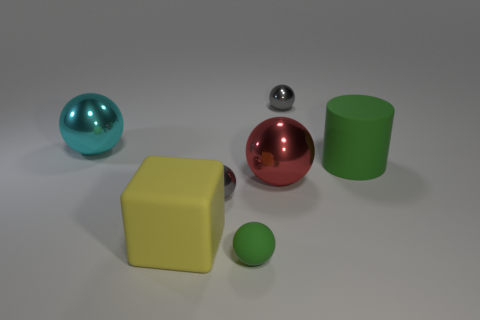There is another thing that is the same color as the tiny matte thing; what material is it?
Your answer should be very brief. Rubber. Are there any tiny spheres that are on the left side of the large shiny ball that is in front of the big cylinder?
Ensure brevity in your answer.  Yes. There is a ball that is behind the large green rubber cylinder and to the left of the big red ball; what is its size?
Offer a terse response. Large. What number of green things are metallic things or big objects?
Offer a terse response. 1. The red metal object that is the same size as the yellow thing is what shape?
Ensure brevity in your answer.  Sphere. How many other objects are there of the same color as the large rubber block?
Offer a very short reply. 0. What size is the red metal ball in front of the big cyan object on the left side of the tiny rubber sphere?
Your answer should be very brief. Large. Is the green object on the right side of the green matte sphere made of the same material as the red object?
Make the answer very short. No. The metal object behind the cyan shiny sphere has what shape?
Offer a very short reply. Sphere. What number of other rubber cubes are the same size as the yellow block?
Provide a succinct answer. 0. 